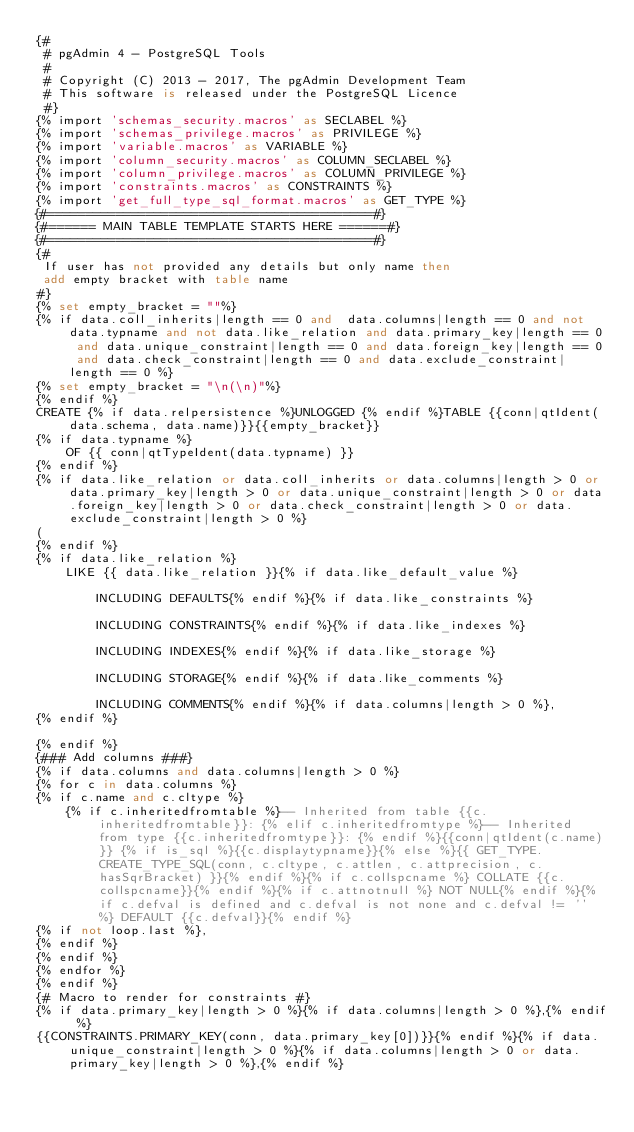<code> <loc_0><loc_0><loc_500><loc_500><_SQL_>{#
 # pgAdmin 4 - PostgreSQL Tools
 #
 # Copyright (C) 2013 - 2017, The pgAdmin Development Team
 # This software is released under the PostgreSQL Licence
 #}
{% import 'schemas_security.macros' as SECLABEL %}
{% import 'schemas_privilege.macros' as PRIVILEGE %}
{% import 'variable.macros' as VARIABLE %}
{% import 'column_security.macros' as COLUMN_SECLABEL %}
{% import 'column_privilege.macros' as COLUMN_PRIVILEGE %}
{% import 'constraints.macros' as CONSTRAINTS %}
{% import 'get_full_type_sql_format.macros' as GET_TYPE %}
{#===========================================#}
{#====== MAIN TABLE TEMPLATE STARTS HERE ======#}
{#===========================================#}
{#
 If user has not provided any details but only name then
 add empty bracket with table name
#}
{% set empty_bracket = ""%}
{% if data.coll_inherits|length == 0 and  data.columns|length == 0 and not data.typname and not data.like_relation and data.primary_key|length == 0 and data.unique_constraint|length == 0 and data.foreign_key|length == 0 and data.check_constraint|length == 0 and data.exclude_constraint|length == 0 %}
{% set empty_bracket = "\n(\n)"%}
{% endif %}
CREATE {% if data.relpersistence %}UNLOGGED {% endif %}TABLE {{conn|qtIdent(data.schema, data.name)}}{{empty_bracket}}
{% if data.typname %}
    OF {{ conn|qtTypeIdent(data.typname) }}
{% endif %}
{% if data.like_relation or data.coll_inherits or data.columns|length > 0 or data.primary_key|length > 0 or data.unique_constraint|length > 0 or data.foreign_key|length > 0 or data.check_constraint|length > 0 or data.exclude_constraint|length > 0 %}
(
{% endif %}
{% if data.like_relation %}
    LIKE {{ data.like_relation }}{% if data.like_default_value %}

        INCLUDING DEFAULTS{% endif %}{% if data.like_constraints %}

        INCLUDING CONSTRAINTS{% endif %}{% if data.like_indexes %}

        INCLUDING INDEXES{% endif %}{% if data.like_storage %}

        INCLUDING STORAGE{% endif %}{% if data.like_comments %}

        INCLUDING COMMENTS{% endif %}{% if data.columns|length > 0 %},
{% endif %}

{% endif %}
{### Add columns ###}
{% if data.columns and data.columns|length > 0 %}
{% for c in data.columns %}
{% if c.name and c.cltype %}
    {% if c.inheritedfromtable %}-- Inherited from table {{c.inheritedfromtable}}: {% elif c.inheritedfromtype %}-- Inherited from type {{c.inheritedfromtype}}: {% endif %}{{conn|qtIdent(c.name)}} {% if is_sql %}{{c.displaytypname}}{% else %}{{ GET_TYPE.CREATE_TYPE_SQL(conn, c.cltype, c.attlen, c.attprecision, c.hasSqrBracket) }}{% endif %}{% if c.collspcname %} COLLATE {{c.collspcname}}{% endif %}{% if c.attnotnull %} NOT NULL{% endif %}{% if c.defval is defined and c.defval is not none and c.defval != '' %} DEFAULT {{c.defval}}{% endif %}
{% if not loop.last %},
{% endif %}
{% endif %}
{% endfor %}
{% endif %}
{# Macro to render for constraints #}
{% if data.primary_key|length > 0 %}{% if data.columns|length > 0 %},{% endif %}
{{CONSTRAINTS.PRIMARY_KEY(conn, data.primary_key[0])}}{% endif %}{% if data.unique_constraint|length > 0 %}{% if data.columns|length > 0 or data.primary_key|length > 0 %},{% endif %}</code> 